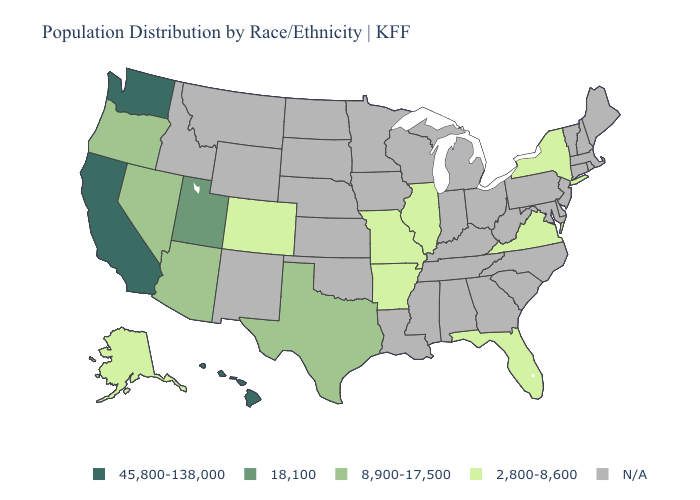Which states have the lowest value in the South?
Keep it brief. Arkansas, Florida, Virginia. What is the value of California?
Give a very brief answer. 45,800-138,000. Does Nevada have the highest value in the USA?
Keep it brief. No. What is the highest value in states that border Oregon?
Concise answer only. 45,800-138,000. Name the states that have a value in the range 45,800-138,000?
Give a very brief answer. California, Hawaii, Washington. What is the value of Ohio?
Short answer required. N/A. What is the value of Kansas?
Keep it brief. N/A. Does the map have missing data?
Quick response, please. Yes. Does the first symbol in the legend represent the smallest category?
Be succinct. No. Does the map have missing data?
Concise answer only. Yes. Does Colorado have the highest value in the USA?
Quick response, please. No. Name the states that have a value in the range 45,800-138,000?
Short answer required. California, Hawaii, Washington. 